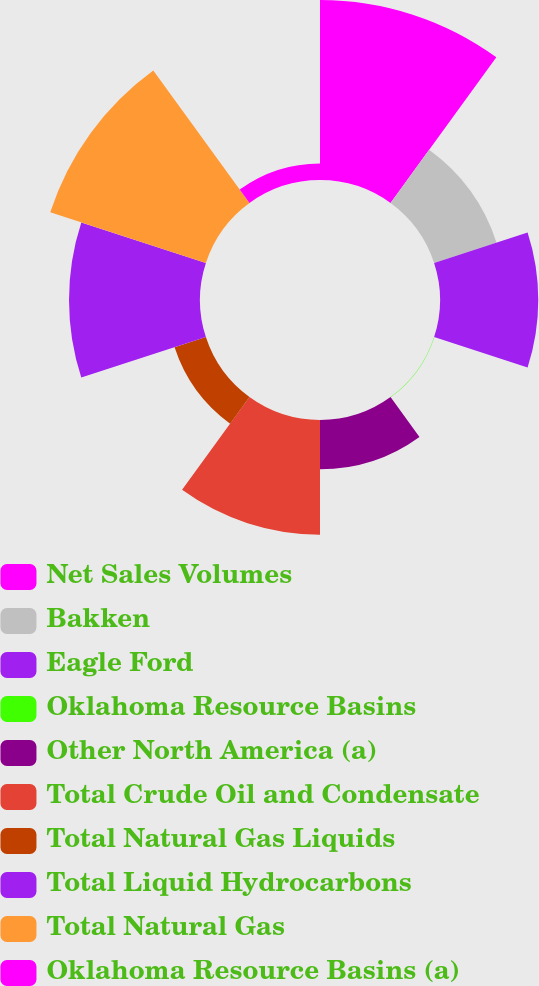Convert chart. <chart><loc_0><loc_0><loc_500><loc_500><pie_chart><fcel>Net Sales Volumes<fcel>Bakken<fcel>Eagle Ford<fcel>Oklahoma Resource Basins<fcel>Other North America (a)<fcel>Total Crude Oil and Condensate<fcel>Total Natural Gas Liquids<fcel>Total Liquid Hydrocarbons<fcel>Total Natural Gas<fcel>Oklahoma Resource Basins (a)<nl><fcel>21.12%<fcel>7.7%<fcel>11.53%<fcel>0.03%<fcel>5.78%<fcel>13.45%<fcel>3.86%<fcel>15.37%<fcel>19.2%<fcel>1.95%<nl></chart> 